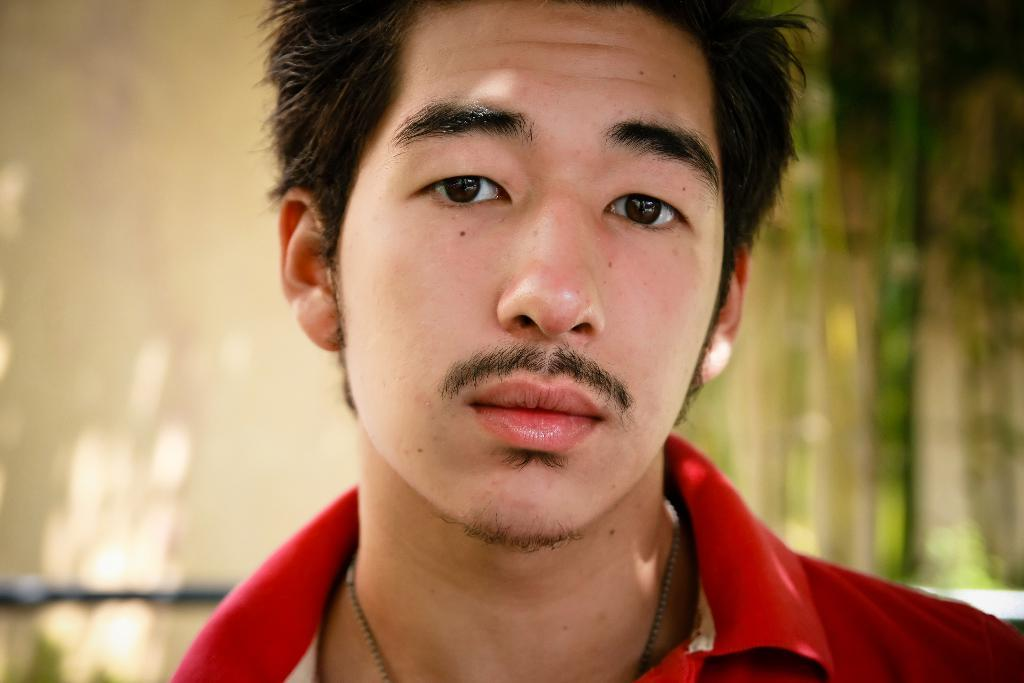Who is present in the image? There is a man in the image. What is the man wearing? The man is wearing a red t-shirt. What can be seen in the background of the image? There are trees in the background of the image. How many snails are crawling on the man's red t-shirt in the image? There are no snails visible on the man's red t-shirt in the image. 